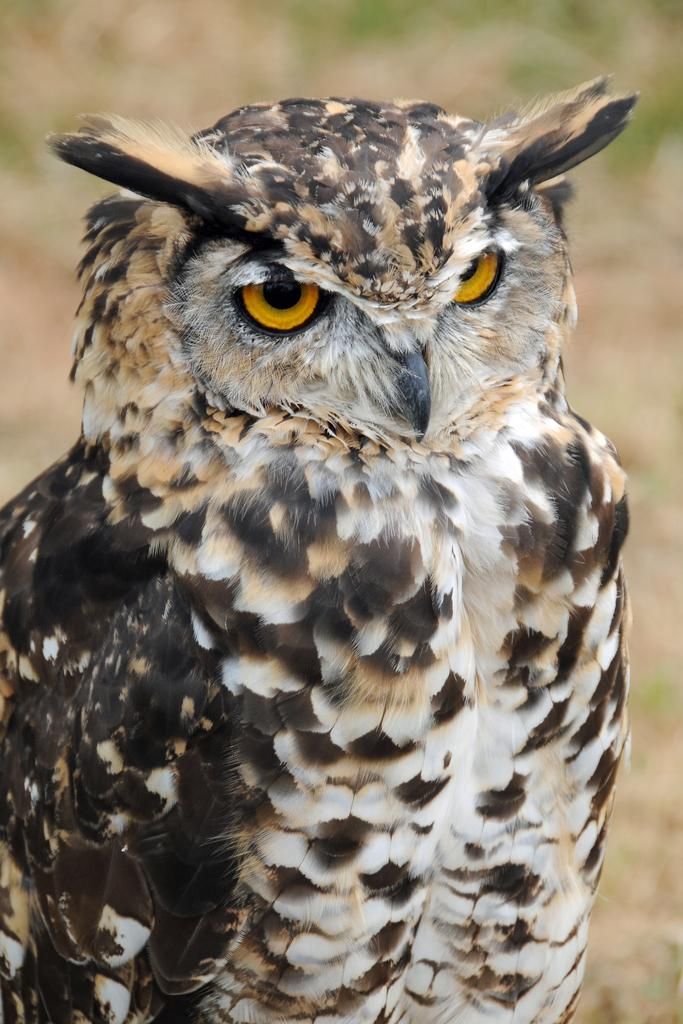What type of animal is in the image? The image contains an owl. Can you describe the color of the owl? The owl is white and black in color. Is the owl stuck in quicksand in the image? No, there is no quicksand present in the image, and the owl is not depicted in any such situation. 